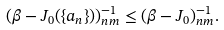Convert formula to latex. <formula><loc_0><loc_0><loc_500><loc_500>( \beta - J _ { 0 } ( \{ a _ { n } \} ) ) _ { n m } ^ { - 1 } \leq ( \beta - J _ { 0 } ) _ { n m } ^ { - 1 } .</formula> 